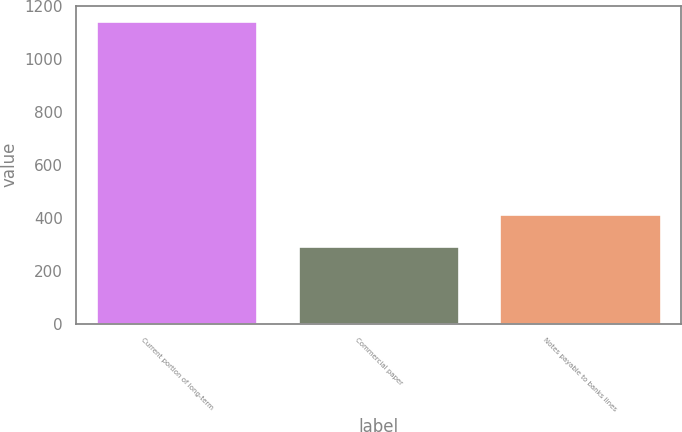Convert chart to OTSL. <chart><loc_0><loc_0><loc_500><loc_500><bar_chart><fcel>Current portion of long-term<fcel>Commercial paper<fcel>Notes payable to banks lines<nl><fcel>1143<fcel>294<fcel>413<nl></chart> 